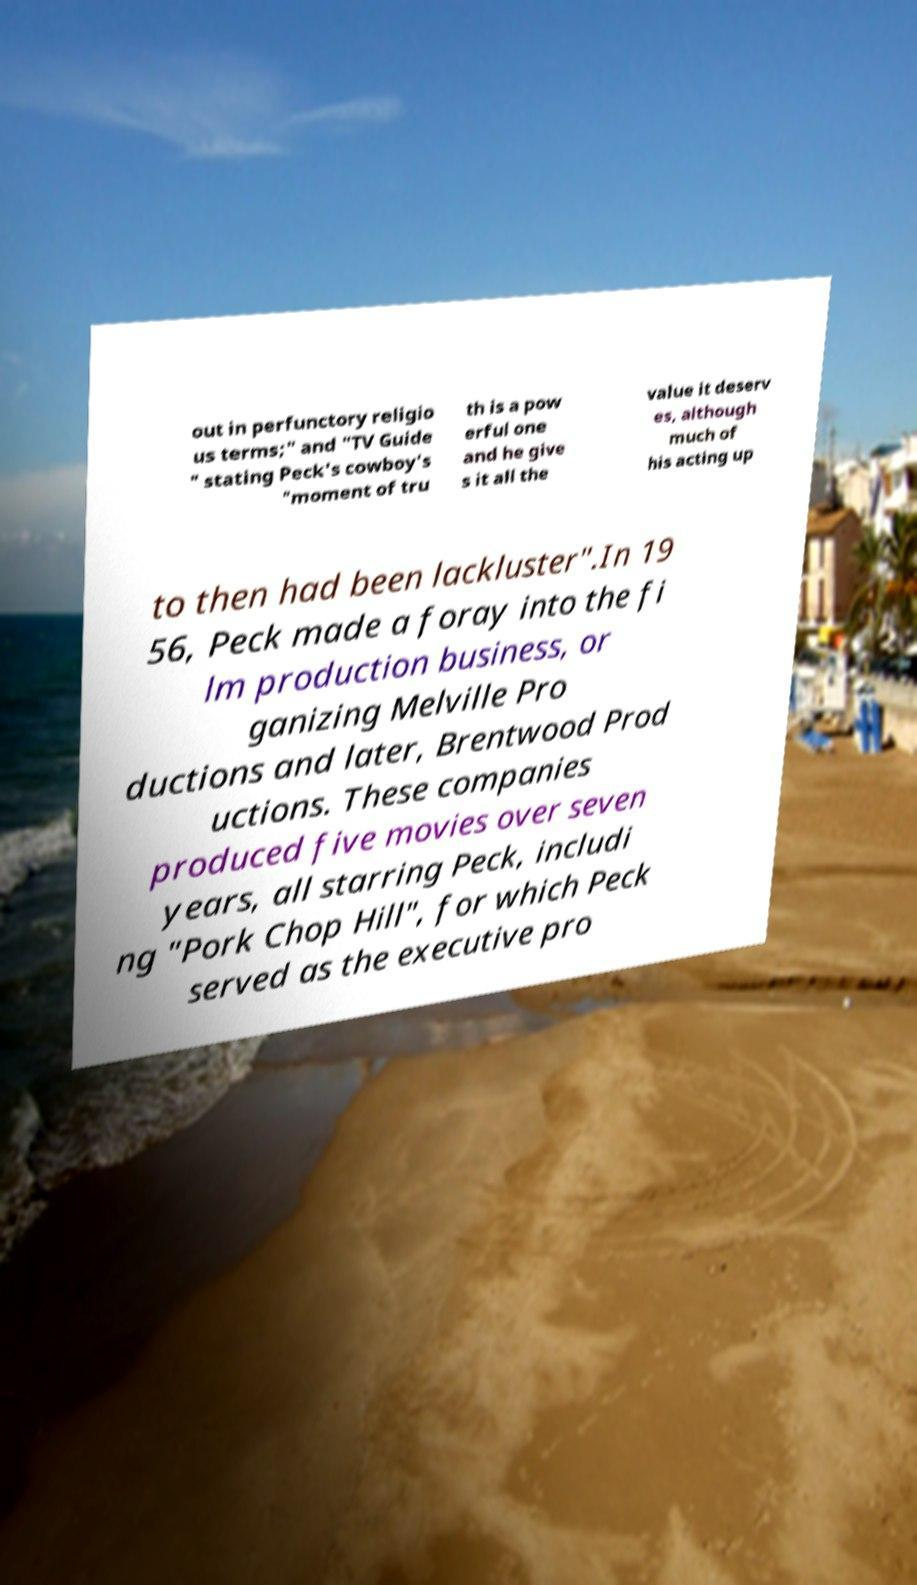Can you accurately transcribe the text from the provided image for me? out in perfunctory religio us terms;" and "TV Guide " stating Peck's cowboy's "moment of tru th is a pow erful one and he give s it all the value it deserv es, although much of his acting up to then had been lackluster".In 19 56, Peck made a foray into the fi lm production business, or ganizing Melville Pro ductions and later, Brentwood Prod uctions. These companies produced five movies over seven years, all starring Peck, includi ng "Pork Chop Hill", for which Peck served as the executive pro 